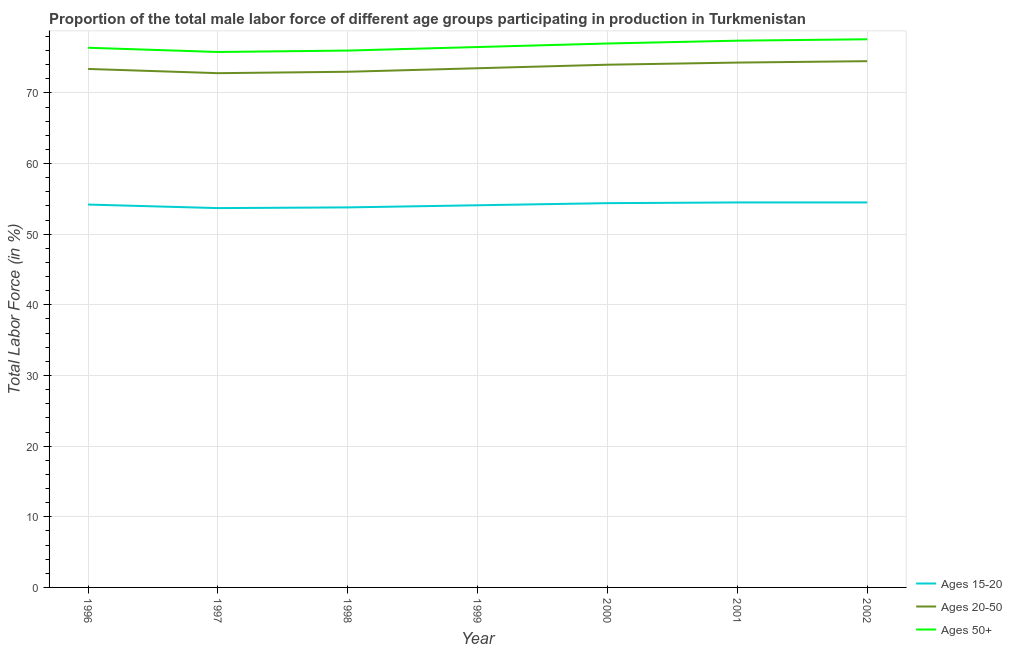Does the line corresponding to percentage of male labor force within the age group 15-20 intersect with the line corresponding to percentage of male labor force within the age group 20-50?
Your response must be concise. No. Across all years, what is the maximum percentage of male labor force above age 50?
Ensure brevity in your answer.  77.6. Across all years, what is the minimum percentage of male labor force within the age group 15-20?
Offer a very short reply. 53.7. In which year was the percentage of male labor force above age 50 maximum?
Offer a terse response. 2002. In which year was the percentage of male labor force within the age group 20-50 minimum?
Your answer should be compact. 1997. What is the total percentage of male labor force within the age group 15-20 in the graph?
Make the answer very short. 379.2. What is the difference between the percentage of male labor force within the age group 15-20 in 2000 and that in 2002?
Offer a very short reply. -0.1. What is the difference between the percentage of male labor force above age 50 in 1999 and the percentage of male labor force within the age group 15-20 in 2000?
Offer a very short reply. 22.1. What is the average percentage of male labor force within the age group 15-20 per year?
Keep it short and to the point. 54.17. In the year 1996, what is the difference between the percentage of male labor force within the age group 15-20 and percentage of male labor force within the age group 20-50?
Give a very brief answer. -19.2. What is the ratio of the percentage of male labor force within the age group 20-50 in 1999 to that in 2002?
Your answer should be very brief. 0.99. Is the percentage of male labor force within the age group 20-50 in 1996 less than that in 1999?
Offer a very short reply. Yes. What is the difference between the highest and the lowest percentage of male labor force within the age group 15-20?
Offer a terse response. 0.8. Is the percentage of male labor force above age 50 strictly greater than the percentage of male labor force within the age group 15-20 over the years?
Keep it short and to the point. Yes. Is the percentage of male labor force within the age group 15-20 strictly less than the percentage of male labor force above age 50 over the years?
Offer a terse response. Yes. What is the difference between two consecutive major ticks on the Y-axis?
Ensure brevity in your answer.  10. Does the graph contain grids?
Offer a very short reply. Yes. How many legend labels are there?
Offer a very short reply. 3. What is the title of the graph?
Make the answer very short. Proportion of the total male labor force of different age groups participating in production in Turkmenistan. Does "Agricultural raw materials" appear as one of the legend labels in the graph?
Offer a very short reply. No. What is the label or title of the X-axis?
Offer a very short reply. Year. What is the Total Labor Force (in %) in Ages 15-20 in 1996?
Provide a short and direct response. 54.2. What is the Total Labor Force (in %) in Ages 20-50 in 1996?
Make the answer very short. 73.4. What is the Total Labor Force (in %) of Ages 50+ in 1996?
Keep it short and to the point. 76.4. What is the Total Labor Force (in %) in Ages 15-20 in 1997?
Keep it short and to the point. 53.7. What is the Total Labor Force (in %) in Ages 20-50 in 1997?
Offer a very short reply. 72.8. What is the Total Labor Force (in %) of Ages 50+ in 1997?
Your answer should be very brief. 75.8. What is the Total Labor Force (in %) in Ages 15-20 in 1998?
Provide a short and direct response. 53.8. What is the Total Labor Force (in %) in Ages 20-50 in 1998?
Your answer should be very brief. 73. What is the Total Labor Force (in %) in Ages 50+ in 1998?
Provide a short and direct response. 76. What is the Total Labor Force (in %) in Ages 15-20 in 1999?
Offer a terse response. 54.1. What is the Total Labor Force (in %) of Ages 20-50 in 1999?
Make the answer very short. 73.5. What is the Total Labor Force (in %) in Ages 50+ in 1999?
Your answer should be compact. 76.5. What is the Total Labor Force (in %) in Ages 15-20 in 2000?
Offer a very short reply. 54.4. What is the Total Labor Force (in %) of Ages 50+ in 2000?
Keep it short and to the point. 77. What is the Total Labor Force (in %) in Ages 15-20 in 2001?
Offer a very short reply. 54.5. What is the Total Labor Force (in %) of Ages 20-50 in 2001?
Make the answer very short. 74.3. What is the Total Labor Force (in %) of Ages 50+ in 2001?
Provide a short and direct response. 77.4. What is the Total Labor Force (in %) of Ages 15-20 in 2002?
Provide a short and direct response. 54.5. What is the Total Labor Force (in %) in Ages 20-50 in 2002?
Provide a short and direct response. 74.5. What is the Total Labor Force (in %) in Ages 50+ in 2002?
Make the answer very short. 77.6. Across all years, what is the maximum Total Labor Force (in %) in Ages 15-20?
Make the answer very short. 54.5. Across all years, what is the maximum Total Labor Force (in %) in Ages 20-50?
Your response must be concise. 74.5. Across all years, what is the maximum Total Labor Force (in %) of Ages 50+?
Your answer should be compact. 77.6. Across all years, what is the minimum Total Labor Force (in %) in Ages 15-20?
Ensure brevity in your answer.  53.7. Across all years, what is the minimum Total Labor Force (in %) of Ages 20-50?
Provide a short and direct response. 72.8. Across all years, what is the minimum Total Labor Force (in %) of Ages 50+?
Make the answer very short. 75.8. What is the total Total Labor Force (in %) in Ages 15-20 in the graph?
Ensure brevity in your answer.  379.2. What is the total Total Labor Force (in %) in Ages 20-50 in the graph?
Provide a short and direct response. 515.5. What is the total Total Labor Force (in %) of Ages 50+ in the graph?
Provide a succinct answer. 536.7. What is the difference between the Total Labor Force (in %) of Ages 20-50 in 1996 and that in 1997?
Your answer should be compact. 0.6. What is the difference between the Total Labor Force (in %) in Ages 50+ in 1996 and that in 1997?
Your answer should be very brief. 0.6. What is the difference between the Total Labor Force (in %) in Ages 15-20 in 1996 and that in 1998?
Your answer should be compact. 0.4. What is the difference between the Total Labor Force (in %) in Ages 20-50 in 1996 and that in 1998?
Provide a succinct answer. 0.4. What is the difference between the Total Labor Force (in %) of Ages 15-20 in 1996 and that in 1999?
Keep it short and to the point. 0.1. What is the difference between the Total Labor Force (in %) in Ages 50+ in 1996 and that in 1999?
Your response must be concise. -0.1. What is the difference between the Total Labor Force (in %) in Ages 50+ in 1996 and that in 2000?
Provide a short and direct response. -0.6. What is the difference between the Total Labor Force (in %) of Ages 50+ in 1996 and that in 2001?
Your answer should be very brief. -1. What is the difference between the Total Labor Force (in %) of Ages 50+ in 1996 and that in 2002?
Provide a short and direct response. -1.2. What is the difference between the Total Labor Force (in %) in Ages 50+ in 1997 and that in 1998?
Give a very brief answer. -0.2. What is the difference between the Total Labor Force (in %) in Ages 20-50 in 1997 and that in 1999?
Make the answer very short. -0.7. What is the difference between the Total Labor Force (in %) of Ages 15-20 in 1997 and that in 2000?
Your answer should be very brief. -0.7. What is the difference between the Total Labor Force (in %) in Ages 20-50 in 1997 and that in 2000?
Provide a succinct answer. -1.2. What is the difference between the Total Labor Force (in %) of Ages 50+ in 1997 and that in 2001?
Offer a very short reply. -1.6. What is the difference between the Total Labor Force (in %) in Ages 15-20 in 1997 and that in 2002?
Offer a very short reply. -0.8. What is the difference between the Total Labor Force (in %) of Ages 15-20 in 1998 and that in 1999?
Offer a terse response. -0.3. What is the difference between the Total Labor Force (in %) in Ages 20-50 in 1998 and that in 1999?
Make the answer very short. -0.5. What is the difference between the Total Labor Force (in %) of Ages 50+ in 1998 and that in 1999?
Make the answer very short. -0.5. What is the difference between the Total Labor Force (in %) in Ages 15-20 in 1998 and that in 2000?
Offer a terse response. -0.6. What is the difference between the Total Labor Force (in %) of Ages 20-50 in 1998 and that in 2000?
Your answer should be compact. -1. What is the difference between the Total Labor Force (in %) in Ages 15-20 in 1998 and that in 2001?
Ensure brevity in your answer.  -0.7. What is the difference between the Total Labor Force (in %) of Ages 20-50 in 1998 and that in 2001?
Your answer should be compact. -1.3. What is the difference between the Total Labor Force (in %) of Ages 15-20 in 1998 and that in 2002?
Keep it short and to the point. -0.7. What is the difference between the Total Labor Force (in %) in Ages 15-20 in 1999 and that in 2000?
Offer a very short reply. -0.3. What is the difference between the Total Labor Force (in %) of Ages 20-50 in 1999 and that in 2000?
Keep it short and to the point. -0.5. What is the difference between the Total Labor Force (in %) in Ages 15-20 in 1999 and that in 2001?
Ensure brevity in your answer.  -0.4. What is the difference between the Total Labor Force (in %) in Ages 20-50 in 1999 and that in 2001?
Provide a short and direct response. -0.8. What is the difference between the Total Labor Force (in %) in Ages 50+ in 1999 and that in 2001?
Your answer should be very brief. -0.9. What is the difference between the Total Labor Force (in %) of Ages 20-50 in 1999 and that in 2002?
Ensure brevity in your answer.  -1. What is the difference between the Total Labor Force (in %) of Ages 15-20 in 2000 and that in 2001?
Provide a succinct answer. -0.1. What is the difference between the Total Labor Force (in %) of Ages 50+ in 2000 and that in 2002?
Give a very brief answer. -0.6. What is the difference between the Total Labor Force (in %) in Ages 50+ in 2001 and that in 2002?
Offer a very short reply. -0.2. What is the difference between the Total Labor Force (in %) of Ages 15-20 in 1996 and the Total Labor Force (in %) of Ages 20-50 in 1997?
Give a very brief answer. -18.6. What is the difference between the Total Labor Force (in %) in Ages 15-20 in 1996 and the Total Labor Force (in %) in Ages 50+ in 1997?
Your answer should be very brief. -21.6. What is the difference between the Total Labor Force (in %) of Ages 20-50 in 1996 and the Total Labor Force (in %) of Ages 50+ in 1997?
Make the answer very short. -2.4. What is the difference between the Total Labor Force (in %) of Ages 15-20 in 1996 and the Total Labor Force (in %) of Ages 20-50 in 1998?
Your response must be concise. -18.8. What is the difference between the Total Labor Force (in %) of Ages 15-20 in 1996 and the Total Labor Force (in %) of Ages 50+ in 1998?
Provide a short and direct response. -21.8. What is the difference between the Total Labor Force (in %) in Ages 20-50 in 1996 and the Total Labor Force (in %) in Ages 50+ in 1998?
Make the answer very short. -2.6. What is the difference between the Total Labor Force (in %) in Ages 15-20 in 1996 and the Total Labor Force (in %) in Ages 20-50 in 1999?
Give a very brief answer. -19.3. What is the difference between the Total Labor Force (in %) of Ages 15-20 in 1996 and the Total Labor Force (in %) of Ages 50+ in 1999?
Keep it short and to the point. -22.3. What is the difference between the Total Labor Force (in %) in Ages 20-50 in 1996 and the Total Labor Force (in %) in Ages 50+ in 1999?
Provide a short and direct response. -3.1. What is the difference between the Total Labor Force (in %) in Ages 15-20 in 1996 and the Total Labor Force (in %) in Ages 20-50 in 2000?
Offer a terse response. -19.8. What is the difference between the Total Labor Force (in %) in Ages 15-20 in 1996 and the Total Labor Force (in %) in Ages 50+ in 2000?
Your answer should be very brief. -22.8. What is the difference between the Total Labor Force (in %) in Ages 15-20 in 1996 and the Total Labor Force (in %) in Ages 20-50 in 2001?
Your answer should be very brief. -20.1. What is the difference between the Total Labor Force (in %) of Ages 15-20 in 1996 and the Total Labor Force (in %) of Ages 50+ in 2001?
Offer a very short reply. -23.2. What is the difference between the Total Labor Force (in %) in Ages 15-20 in 1996 and the Total Labor Force (in %) in Ages 20-50 in 2002?
Give a very brief answer. -20.3. What is the difference between the Total Labor Force (in %) of Ages 15-20 in 1996 and the Total Labor Force (in %) of Ages 50+ in 2002?
Ensure brevity in your answer.  -23.4. What is the difference between the Total Labor Force (in %) in Ages 20-50 in 1996 and the Total Labor Force (in %) in Ages 50+ in 2002?
Keep it short and to the point. -4.2. What is the difference between the Total Labor Force (in %) in Ages 15-20 in 1997 and the Total Labor Force (in %) in Ages 20-50 in 1998?
Your answer should be very brief. -19.3. What is the difference between the Total Labor Force (in %) of Ages 15-20 in 1997 and the Total Labor Force (in %) of Ages 50+ in 1998?
Your answer should be very brief. -22.3. What is the difference between the Total Labor Force (in %) of Ages 20-50 in 1997 and the Total Labor Force (in %) of Ages 50+ in 1998?
Provide a short and direct response. -3.2. What is the difference between the Total Labor Force (in %) in Ages 15-20 in 1997 and the Total Labor Force (in %) in Ages 20-50 in 1999?
Keep it short and to the point. -19.8. What is the difference between the Total Labor Force (in %) of Ages 15-20 in 1997 and the Total Labor Force (in %) of Ages 50+ in 1999?
Give a very brief answer. -22.8. What is the difference between the Total Labor Force (in %) of Ages 20-50 in 1997 and the Total Labor Force (in %) of Ages 50+ in 1999?
Offer a very short reply. -3.7. What is the difference between the Total Labor Force (in %) of Ages 15-20 in 1997 and the Total Labor Force (in %) of Ages 20-50 in 2000?
Keep it short and to the point. -20.3. What is the difference between the Total Labor Force (in %) of Ages 15-20 in 1997 and the Total Labor Force (in %) of Ages 50+ in 2000?
Make the answer very short. -23.3. What is the difference between the Total Labor Force (in %) of Ages 15-20 in 1997 and the Total Labor Force (in %) of Ages 20-50 in 2001?
Offer a terse response. -20.6. What is the difference between the Total Labor Force (in %) of Ages 15-20 in 1997 and the Total Labor Force (in %) of Ages 50+ in 2001?
Provide a short and direct response. -23.7. What is the difference between the Total Labor Force (in %) in Ages 20-50 in 1997 and the Total Labor Force (in %) in Ages 50+ in 2001?
Make the answer very short. -4.6. What is the difference between the Total Labor Force (in %) in Ages 15-20 in 1997 and the Total Labor Force (in %) in Ages 20-50 in 2002?
Offer a terse response. -20.8. What is the difference between the Total Labor Force (in %) of Ages 15-20 in 1997 and the Total Labor Force (in %) of Ages 50+ in 2002?
Your answer should be very brief. -23.9. What is the difference between the Total Labor Force (in %) in Ages 20-50 in 1997 and the Total Labor Force (in %) in Ages 50+ in 2002?
Provide a succinct answer. -4.8. What is the difference between the Total Labor Force (in %) in Ages 15-20 in 1998 and the Total Labor Force (in %) in Ages 20-50 in 1999?
Offer a very short reply. -19.7. What is the difference between the Total Labor Force (in %) of Ages 15-20 in 1998 and the Total Labor Force (in %) of Ages 50+ in 1999?
Provide a short and direct response. -22.7. What is the difference between the Total Labor Force (in %) in Ages 15-20 in 1998 and the Total Labor Force (in %) in Ages 20-50 in 2000?
Ensure brevity in your answer.  -20.2. What is the difference between the Total Labor Force (in %) of Ages 15-20 in 1998 and the Total Labor Force (in %) of Ages 50+ in 2000?
Make the answer very short. -23.2. What is the difference between the Total Labor Force (in %) in Ages 20-50 in 1998 and the Total Labor Force (in %) in Ages 50+ in 2000?
Offer a very short reply. -4. What is the difference between the Total Labor Force (in %) in Ages 15-20 in 1998 and the Total Labor Force (in %) in Ages 20-50 in 2001?
Your answer should be very brief. -20.5. What is the difference between the Total Labor Force (in %) of Ages 15-20 in 1998 and the Total Labor Force (in %) of Ages 50+ in 2001?
Offer a very short reply. -23.6. What is the difference between the Total Labor Force (in %) in Ages 15-20 in 1998 and the Total Labor Force (in %) in Ages 20-50 in 2002?
Make the answer very short. -20.7. What is the difference between the Total Labor Force (in %) in Ages 15-20 in 1998 and the Total Labor Force (in %) in Ages 50+ in 2002?
Your response must be concise. -23.8. What is the difference between the Total Labor Force (in %) in Ages 20-50 in 1998 and the Total Labor Force (in %) in Ages 50+ in 2002?
Offer a terse response. -4.6. What is the difference between the Total Labor Force (in %) of Ages 15-20 in 1999 and the Total Labor Force (in %) of Ages 20-50 in 2000?
Your answer should be compact. -19.9. What is the difference between the Total Labor Force (in %) in Ages 15-20 in 1999 and the Total Labor Force (in %) in Ages 50+ in 2000?
Your answer should be compact. -22.9. What is the difference between the Total Labor Force (in %) in Ages 15-20 in 1999 and the Total Labor Force (in %) in Ages 20-50 in 2001?
Offer a terse response. -20.2. What is the difference between the Total Labor Force (in %) of Ages 15-20 in 1999 and the Total Labor Force (in %) of Ages 50+ in 2001?
Keep it short and to the point. -23.3. What is the difference between the Total Labor Force (in %) of Ages 15-20 in 1999 and the Total Labor Force (in %) of Ages 20-50 in 2002?
Provide a succinct answer. -20.4. What is the difference between the Total Labor Force (in %) of Ages 15-20 in 1999 and the Total Labor Force (in %) of Ages 50+ in 2002?
Your answer should be compact. -23.5. What is the difference between the Total Labor Force (in %) of Ages 15-20 in 2000 and the Total Labor Force (in %) of Ages 20-50 in 2001?
Your answer should be compact. -19.9. What is the difference between the Total Labor Force (in %) in Ages 15-20 in 2000 and the Total Labor Force (in %) in Ages 20-50 in 2002?
Your answer should be compact. -20.1. What is the difference between the Total Labor Force (in %) in Ages 15-20 in 2000 and the Total Labor Force (in %) in Ages 50+ in 2002?
Make the answer very short. -23.2. What is the difference between the Total Labor Force (in %) of Ages 20-50 in 2000 and the Total Labor Force (in %) of Ages 50+ in 2002?
Offer a terse response. -3.6. What is the difference between the Total Labor Force (in %) in Ages 15-20 in 2001 and the Total Labor Force (in %) in Ages 50+ in 2002?
Give a very brief answer. -23.1. What is the average Total Labor Force (in %) of Ages 15-20 per year?
Your answer should be very brief. 54.17. What is the average Total Labor Force (in %) in Ages 20-50 per year?
Make the answer very short. 73.64. What is the average Total Labor Force (in %) of Ages 50+ per year?
Offer a terse response. 76.67. In the year 1996, what is the difference between the Total Labor Force (in %) of Ages 15-20 and Total Labor Force (in %) of Ages 20-50?
Offer a very short reply. -19.2. In the year 1996, what is the difference between the Total Labor Force (in %) of Ages 15-20 and Total Labor Force (in %) of Ages 50+?
Give a very brief answer. -22.2. In the year 1997, what is the difference between the Total Labor Force (in %) of Ages 15-20 and Total Labor Force (in %) of Ages 20-50?
Provide a succinct answer. -19.1. In the year 1997, what is the difference between the Total Labor Force (in %) of Ages 15-20 and Total Labor Force (in %) of Ages 50+?
Offer a very short reply. -22.1. In the year 1997, what is the difference between the Total Labor Force (in %) in Ages 20-50 and Total Labor Force (in %) in Ages 50+?
Your response must be concise. -3. In the year 1998, what is the difference between the Total Labor Force (in %) in Ages 15-20 and Total Labor Force (in %) in Ages 20-50?
Provide a succinct answer. -19.2. In the year 1998, what is the difference between the Total Labor Force (in %) in Ages 15-20 and Total Labor Force (in %) in Ages 50+?
Provide a short and direct response. -22.2. In the year 1998, what is the difference between the Total Labor Force (in %) in Ages 20-50 and Total Labor Force (in %) in Ages 50+?
Ensure brevity in your answer.  -3. In the year 1999, what is the difference between the Total Labor Force (in %) in Ages 15-20 and Total Labor Force (in %) in Ages 20-50?
Give a very brief answer. -19.4. In the year 1999, what is the difference between the Total Labor Force (in %) in Ages 15-20 and Total Labor Force (in %) in Ages 50+?
Your response must be concise. -22.4. In the year 2000, what is the difference between the Total Labor Force (in %) of Ages 15-20 and Total Labor Force (in %) of Ages 20-50?
Keep it short and to the point. -19.6. In the year 2000, what is the difference between the Total Labor Force (in %) in Ages 15-20 and Total Labor Force (in %) in Ages 50+?
Your response must be concise. -22.6. In the year 2000, what is the difference between the Total Labor Force (in %) in Ages 20-50 and Total Labor Force (in %) in Ages 50+?
Ensure brevity in your answer.  -3. In the year 2001, what is the difference between the Total Labor Force (in %) in Ages 15-20 and Total Labor Force (in %) in Ages 20-50?
Offer a very short reply. -19.8. In the year 2001, what is the difference between the Total Labor Force (in %) of Ages 15-20 and Total Labor Force (in %) of Ages 50+?
Offer a terse response. -22.9. In the year 2001, what is the difference between the Total Labor Force (in %) of Ages 20-50 and Total Labor Force (in %) of Ages 50+?
Provide a short and direct response. -3.1. In the year 2002, what is the difference between the Total Labor Force (in %) in Ages 15-20 and Total Labor Force (in %) in Ages 50+?
Your answer should be very brief. -23.1. What is the ratio of the Total Labor Force (in %) of Ages 15-20 in 1996 to that in 1997?
Your answer should be compact. 1.01. What is the ratio of the Total Labor Force (in %) of Ages 20-50 in 1996 to that in 1997?
Make the answer very short. 1.01. What is the ratio of the Total Labor Force (in %) in Ages 50+ in 1996 to that in 1997?
Provide a short and direct response. 1.01. What is the ratio of the Total Labor Force (in %) of Ages 15-20 in 1996 to that in 1998?
Ensure brevity in your answer.  1.01. What is the ratio of the Total Labor Force (in %) in Ages 20-50 in 1996 to that in 1998?
Make the answer very short. 1.01. What is the ratio of the Total Labor Force (in %) of Ages 50+ in 1996 to that in 1998?
Make the answer very short. 1.01. What is the ratio of the Total Labor Force (in %) of Ages 20-50 in 1996 to that in 1999?
Keep it short and to the point. 1. What is the ratio of the Total Labor Force (in %) in Ages 50+ in 1996 to that in 1999?
Your answer should be compact. 1. What is the ratio of the Total Labor Force (in %) of Ages 15-20 in 1996 to that in 2000?
Offer a terse response. 1. What is the ratio of the Total Labor Force (in %) of Ages 20-50 in 1996 to that in 2001?
Make the answer very short. 0.99. What is the ratio of the Total Labor Force (in %) in Ages 50+ in 1996 to that in 2001?
Your answer should be very brief. 0.99. What is the ratio of the Total Labor Force (in %) in Ages 15-20 in 1996 to that in 2002?
Your answer should be compact. 0.99. What is the ratio of the Total Labor Force (in %) of Ages 20-50 in 1996 to that in 2002?
Give a very brief answer. 0.99. What is the ratio of the Total Labor Force (in %) of Ages 50+ in 1996 to that in 2002?
Provide a succinct answer. 0.98. What is the ratio of the Total Labor Force (in %) of Ages 15-20 in 1997 to that in 1998?
Ensure brevity in your answer.  1. What is the ratio of the Total Labor Force (in %) of Ages 15-20 in 1997 to that in 1999?
Give a very brief answer. 0.99. What is the ratio of the Total Labor Force (in %) in Ages 20-50 in 1997 to that in 1999?
Give a very brief answer. 0.99. What is the ratio of the Total Labor Force (in %) of Ages 50+ in 1997 to that in 1999?
Provide a succinct answer. 0.99. What is the ratio of the Total Labor Force (in %) of Ages 15-20 in 1997 to that in 2000?
Keep it short and to the point. 0.99. What is the ratio of the Total Labor Force (in %) in Ages 20-50 in 1997 to that in 2000?
Provide a short and direct response. 0.98. What is the ratio of the Total Labor Force (in %) in Ages 50+ in 1997 to that in 2000?
Offer a terse response. 0.98. What is the ratio of the Total Labor Force (in %) in Ages 15-20 in 1997 to that in 2001?
Offer a terse response. 0.99. What is the ratio of the Total Labor Force (in %) in Ages 20-50 in 1997 to that in 2001?
Your response must be concise. 0.98. What is the ratio of the Total Labor Force (in %) in Ages 50+ in 1997 to that in 2001?
Make the answer very short. 0.98. What is the ratio of the Total Labor Force (in %) of Ages 20-50 in 1997 to that in 2002?
Offer a terse response. 0.98. What is the ratio of the Total Labor Force (in %) of Ages 50+ in 1997 to that in 2002?
Make the answer very short. 0.98. What is the ratio of the Total Labor Force (in %) of Ages 20-50 in 1998 to that in 1999?
Offer a very short reply. 0.99. What is the ratio of the Total Labor Force (in %) in Ages 50+ in 1998 to that in 1999?
Offer a very short reply. 0.99. What is the ratio of the Total Labor Force (in %) of Ages 20-50 in 1998 to that in 2000?
Your response must be concise. 0.99. What is the ratio of the Total Labor Force (in %) of Ages 15-20 in 1998 to that in 2001?
Your answer should be compact. 0.99. What is the ratio of the Total Labor Force (in %) of Ages 20-50 in 1998 to that in 2001?
Offer a terse response. 0.98. What is the ratio of the Total Labor Force (in %) in Ages 50+ in 1998 to that in 2001?
Make the answer very short. 0.98. What is the ratio of the Total Labor Force (in %) in Ages 15-20 in 1998 to that in 2002?
Make the answer very short. 0.99. What is the ratio of the Total Labor Force (in %) in Ages 20-50 in 1998 to that in 2002?
Your answer should be very brief. 0.98. What is the ratio of the Total Labor Force (in %) in Ages 50+ in 1998 to that in 2002?
Provide a short and direct response. 0.98. What is the ratio of the Total Labor Force (in %) in Ages 15-20 in 1999 to that in 2000?
Your response must be concise. 0.99. What is the ratio of the Total Labor Force (in %) of Ages 20-50 in 1999 to that in 2000?
Your response must be concise. 0.99. What is the ratio of the Total Labor Force (in %) of Ages 15-20 in 1999 to that in 2001?
Offer a very short reply. 0.99. What is the ratio of the Total Labor Force (in %) of Ages 20-50 in 1999 to that in 2001?
Give a very brief answer. 0.99. What is the ratio of the Total Labor Force (in %) in Ages 50+ in 1999 to that in 2001?
Provide a short and direct response. 0.99. What is the ratio of the Total Labor Force (in %) in Ages 20-50 in 1999 to that in 2002?
Provide a succinct answer. 0.99. What is the ratio of the Total Labor Force (in %) of Ages 50+ in 1999 to that in 2002?
Make the answer very short. 0.99. What is the ratio of the Total Labor Force (in %) in Ages 15-20 in 2000 to that in 2002?
Offer a very short reply. 1. What is the ratio of the Total Labor Force (in %) of Ages 15-20 in 2001 to that in 2002?
Provide a succinct answer. 1. What is the ratio of the Total Labor Force (in %) of Ages 20-50 in 2001 to that in 2002?
Offer a very short reply. 1. What is the ratio of the Total Labor Force (in %) of Ages 50+ in 2001 to that in 2002?
Your response must be concise. 1. What is the difference between the highest and the second highest Total Labor Force (in %) in Ages 15-20?
Keep it short and to the point. 0. What is the difference between the highest and the lowest Total Labor Force (in %) in Ages 15-20?
Your response must be concise. 0.8. 